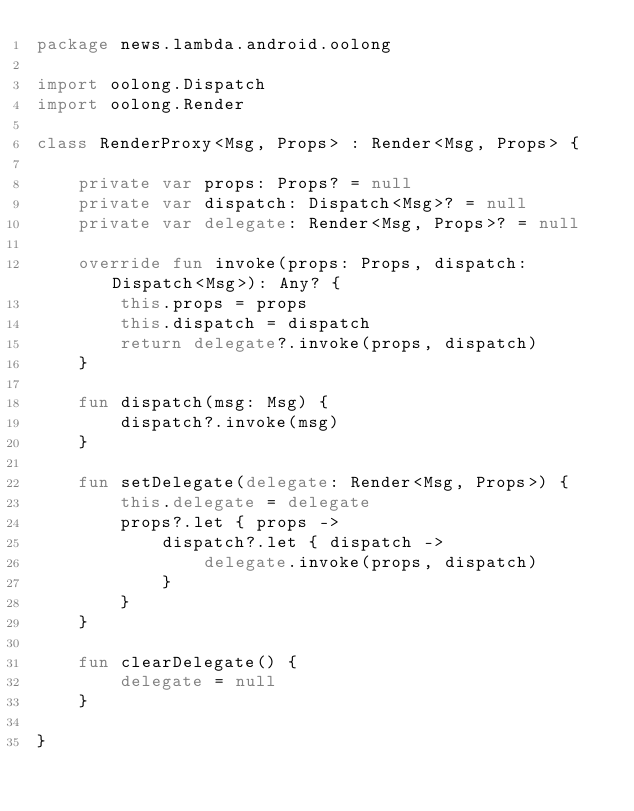Convert code to text. <code><loc_0><loc_0><loc_500><loc_500><_Kotlin_>package news.lambda.android.oolong

import oolong.Dispatch
import oolong.Render

class RenderProxy<Msg, Props> : Render<Msg, Props> {

    private var props: Props? = null
    private var dispatch: Dispatch<Msg>? = null
    private var delegate: Render<Msg, Props>? = null

    override fun invoke(props: Props, dispatch: Dispatch<Msg>): Any? {
        this.props = props
        this.dispatch = dispatch
        return delegate?.invoke(props, dispatch)
    }

    fun dispatch(msg: Msg) {
        dispatch?.invoke(msg)
    }

    fun setDelegate(delegate: Render<Msg, Props>) {
        this.delegate = delegate
        props?.let { props ->
            dispatch?.let { dispatch ->
                delegate.invoke(props, dispatch)
            }
        }
    }

    fun clearDelegate() {
        delegate = null
    }

}
</code> 